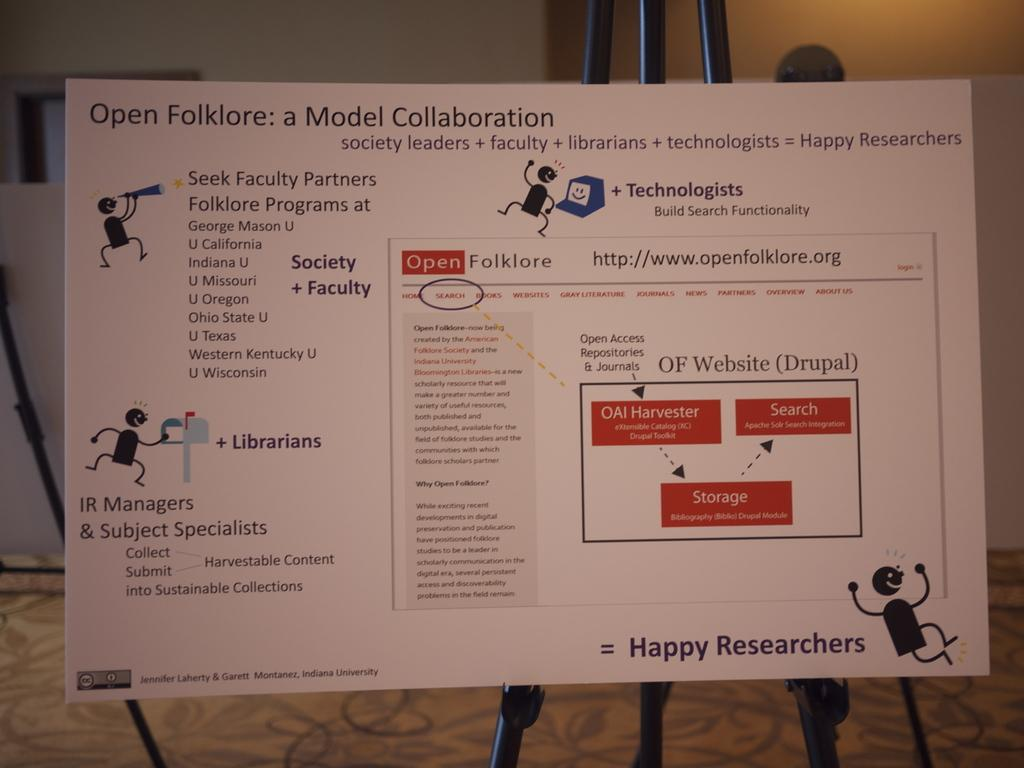<image>
Share a concise interpretation of the image provided. A display board is titled "Open Folklore: a Model Collaboration". 